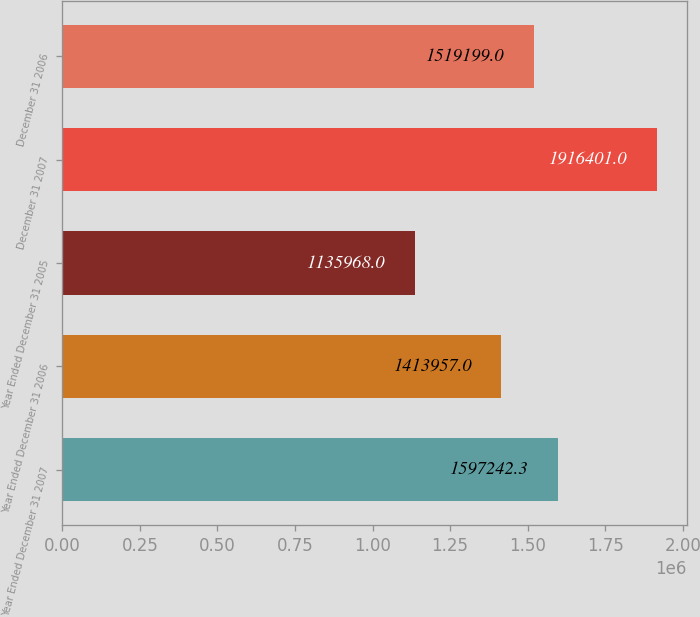<chart> <loc_0><loc_0><loc_500><loc_500><bar_chart><fcel>Year Ended December 31 2007<fcel>Year Ended December 31 2006<fcel>Year Ended December 31 2005<fcel>December 31 2007<fcel>December 31 2006<nl><fcel>1.59724e+06<fcel>1.41396e+06<fcel>1.13597e+06<fcel>1.9164e+06<fcel>1.5192e+06<nl></chart> 